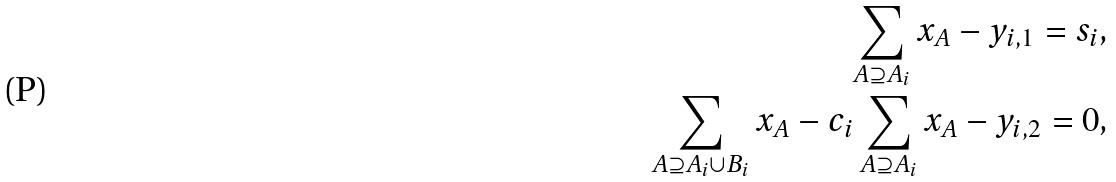<formula> <loc_0><loc_0><loc_500><loc_500>\sum _ { A \supseteq A _ { i } } x _ { A } - y _ { i , 1 } = s _ { i } , \\ \sum _ { A \supseteq A _ { i } \cup B _ { i } } x _ { A } - c _ { i } \sum _ { A \supseteq A _ { i } } x _ { A } - y _ { i , 2 } = 0 ,</formula> 